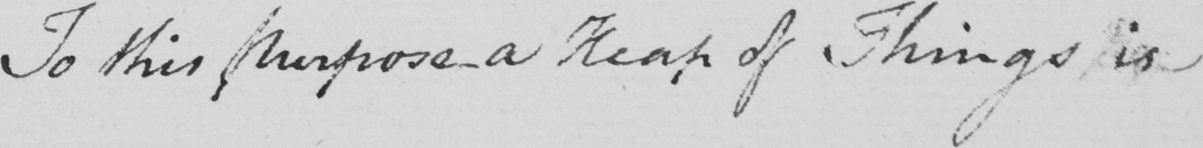Transcribe the text shown in this historical manuscript line. To this purpose a Heap of Things is 